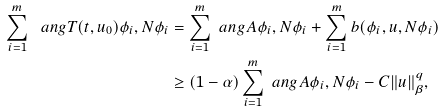<formula> <loc_0><loc_0><loc_500><loc_500>\sum _ { i = 1 } ^ { m } \ a n g { T ( t , u _ { 0 } ) \phi _ { i } , N \phi _ { i } } & = \sum _ { i = 1 } ^ { m } \ a n g { A \phi _ { i } , N \phi _ { i } } + \sum _ { i = 1 } ^ { m } b ( \phi _ { i } , u , N \phi _ { i } ) \\ & \geq ( 1 - \alpha ) \sum _ { i = 1 } ^ { m } \ a n g { A \phi _ { i } , N \phi _ { i } } - C \| u \| _ { \beta } ^ { q } ,</formula> 